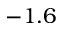Convert formula to latex. <formula><loc_0><loc_0><loc_500><loc_500>- 1 . 6</formula> 